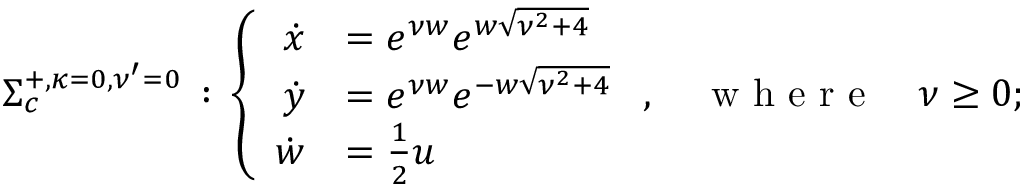Convert formula to latex. <formula><loc_0><loc_0><loc_500><loc_500>\begin{array} { r } { \Sigma _ { c } ^ { + , { \kappa = } 0 , { \nu ^ { \prime } = 0 } } \, \colon \, \left \{ \begin{array} { r l } { \dot { x } } & { = e ^ { \nu w } e ^ { w \sqrt { \nu ^ { 2 } + 4 } } } \\ { \dot { y } } & { = e ^ { \nu w } e ^ { - w \sqrt { \nu ^ { 2 } + 4 } } } \\ { \dot { w } } & { = \frac { 1 } { 2 } u } \end{array} , \quad w h e r e \quad \nu \geq 0 ; } \end{array}</formula> 